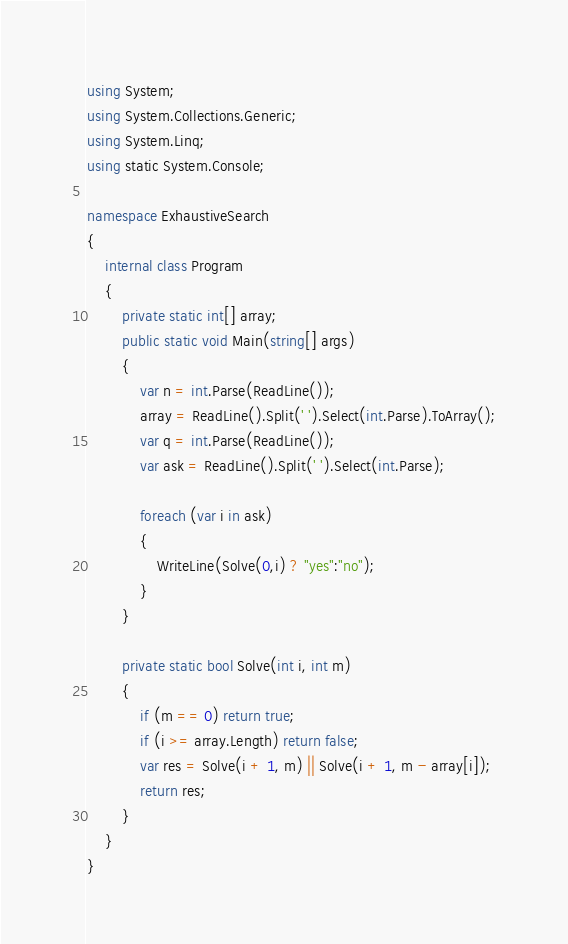<code> <loc_0><loc_0><loc_500><loc_500><_C#_>using System;
using System.Collections.Generic;
using System.Linq;
using static System.Console;

namespace ExhaustiveSearch
{
    internal class Program
    {
        private static int[] array;
        public static void Main(string[] args)
        {
            var n = int.Parse(ReadLine());
            array = ReadLine().Split(' ').Select(int.Parse).ToArray();
            var q = int.Parse(ReadLine());
            var ask = ReadLine().Split(' ').Select(int.Parse);

            foreach (var i in ask)
            {
                WriteLine(Solve(0,i) ? "yes":"no");
            }
        }

        private static bool Solve(int i, int m)
        {
            if (m == 0) return true;
            if (i >= array.Length) return false;
            var res = Solve(i + 1, m) || Solve(i + 1, m - array[i]);
            return res;
        }
    }
}
</code> 